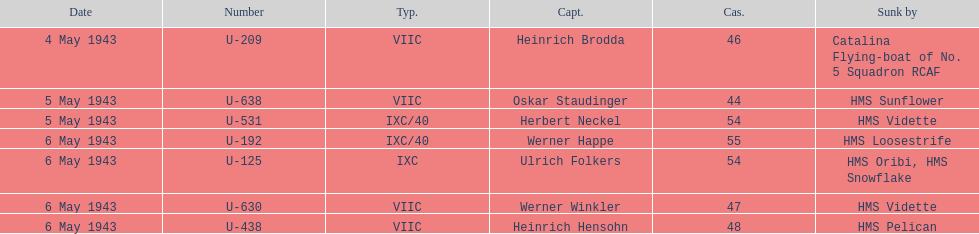What is the unique vessel to sink various u-boats? HMS Vidette. 